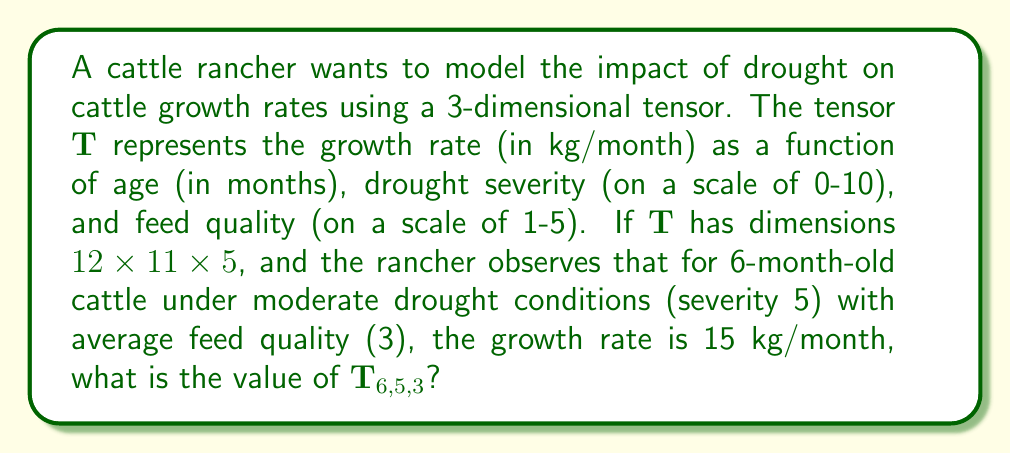Can you solve this math problem? To solve this problem, we need to understand the structure of the tensor $\mathbf{T}$ and how to interpret its indices:

1. The tensor $\mathbf{T}$ has dimensions $12 \times 11 \times 5$, which means:
   - First dimension (age): 12 possible values (0 to 11 months)
   - Second dimension (drought severity): 11 possible values (0 to 10)
   - Third dimension (feed quality): 5 possible values (1 to 5)

2. The indices of $\mathbf{T}$ correspond to:
   - $i$: age in months (0-indexed)
   - $j$: drought severity (0-indexed)
   - $k$: feed quality (1-indexed)

3. For the given scenario:
   - Age: 6 months
   - Drought severity: 5 (moderate)
   - Feed quality: 3 (average)
   - Observed growth rate: 15 kg/month

4. To find the correct tensor element, we need to adjust the indices:
   - Age index: $6$ (no adjustment needed as it's already 0-indexed)
   - Drought severity index: $5$ (no adjustment needed as it's already 0-indexed)
   - Feed quality index: $3$ (no adjustment needed as it's already 1-indexed)

5. Therefore, the tensor element we're looking for is $\mathbf{T}_{6,5,3}$

6. The value of this element is the observed growth rate: 15 kg/month

Thus, $\mathbf{T}_{6,5,3} = 15$.
Answer: $15$ 